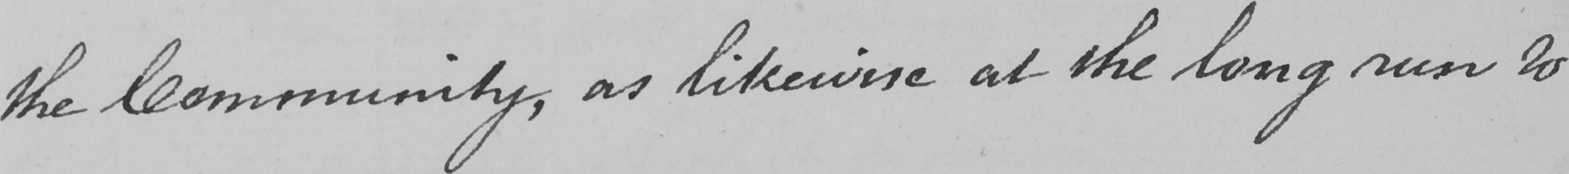What text is written in this handwritten line? the Community , as likewise at the long run to 